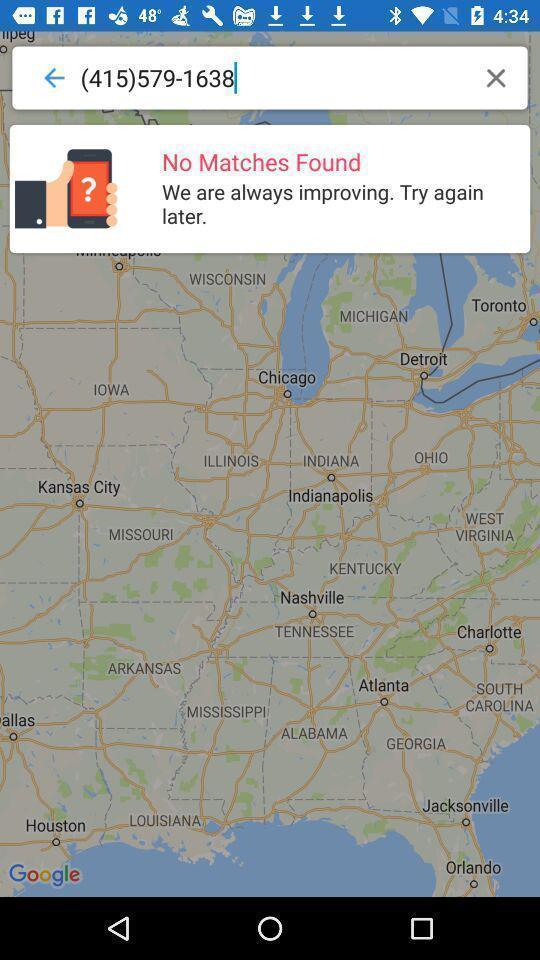What details can you identify in this image? Pop up of no results found in search. 